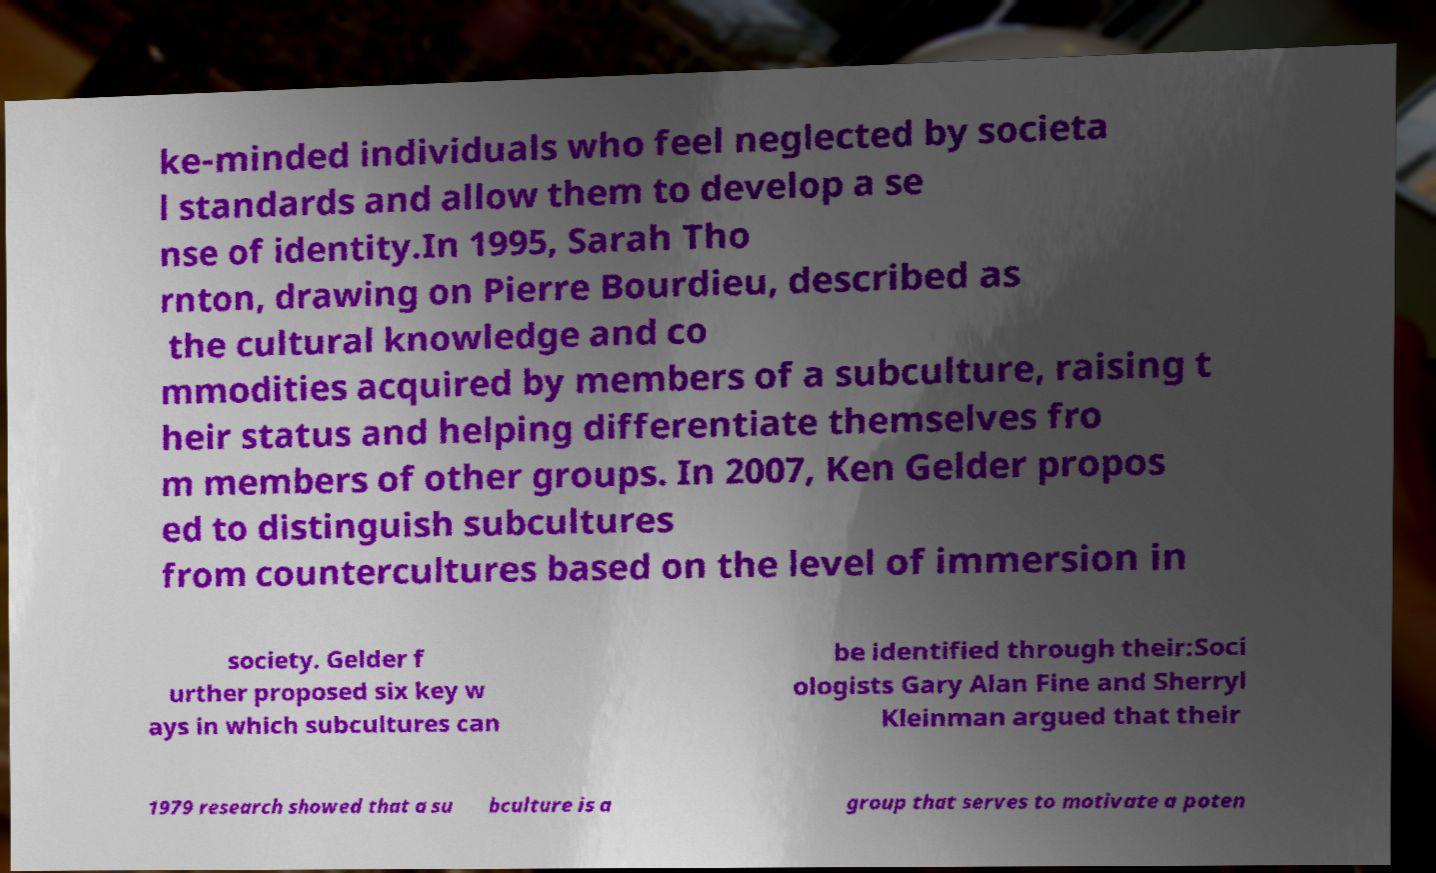Could you extract and type out the text from this image? ke-minded individuals who feel neglected by societa l standards and allow them to develop a se nse of identity.In 1995, Sarah Tho rnton, drawing on Pierre Bourdieu, described as the cultural knowledge and co mmodities acquired by members of a subculture, raising t heir status and helping differentiate themselves fro m members of other groups. In 2007, Ken Gelder propos ed to distinguish subcultures from countercultures based on the level of immersion in society. Gelder f urther proposed six key w ays in which subcultures can be identified through their:Soci ologists Gary Alan Fine and Sherryl Kleinman argued that their 1979 research showed that a su bculture is a group that serves to motivate a poten 